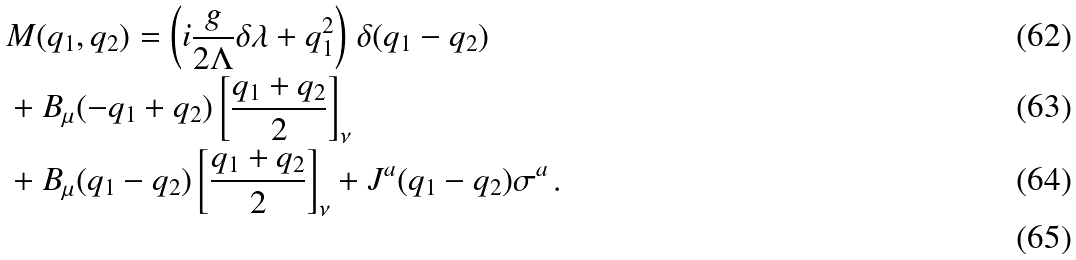Convert formula to latex. <formula><loc_0><loc_0><loc_500><loc_500>& M ( q _ { 1 } , q _ { 2 } ) = \left ( i \frac { g } { 2 \Lambda } \delta \lambda + q _ { 1 } ^ { 2 } \right ) \, \delta ( q _ { 1 } - q _ { 2 } ) \\ & + B _ { \mu } ( - q _ { 1 } + q _ { 2 } ) \left [ \frac { q _ { 1 } + q _ { 2 } } { 2 } \right ] _ { \nu } \\ & + B _ { \mu } ( q _ { 1 } - q _ { 2 } ) \left [ \frac { q _ { 1 } + q _ { 2 } } { 2 } \right ] _ { \nu } + J ^ { a } ( q _ { 1 } - q _ { 2 } ) \sigma ^ { a } \, . \\</formula> 